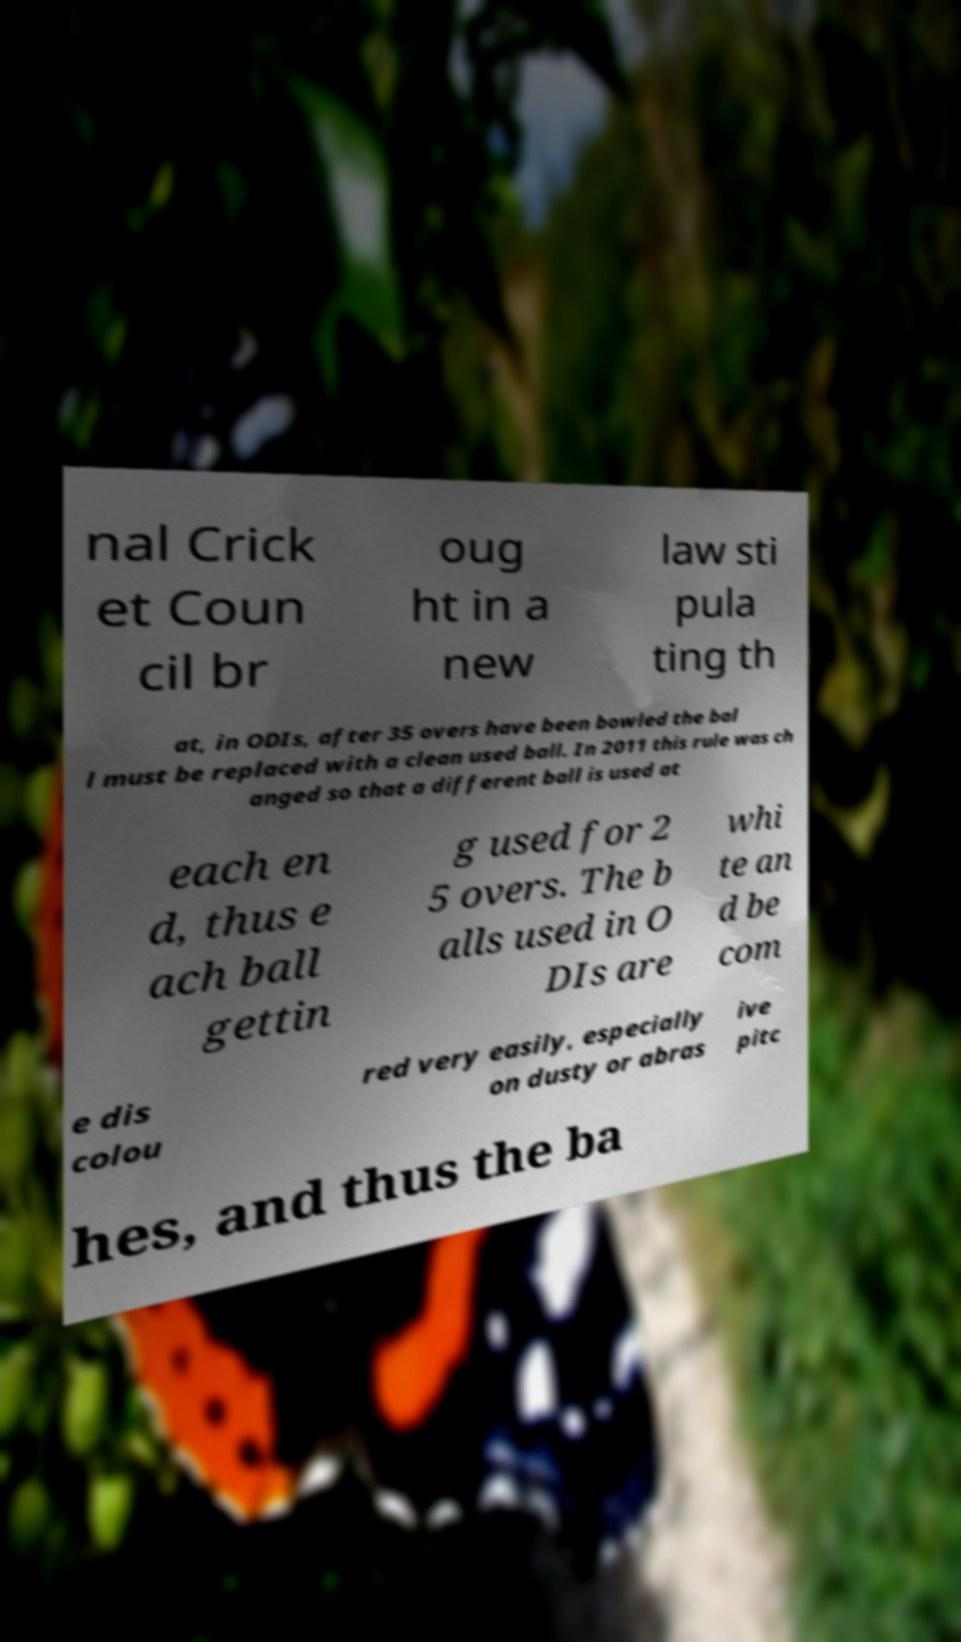What messages or text are displayed in this image? I need them in a readable, typed format. nal Crick et Coun cil br oug ht in a new law sti pula ting th at, in ODIs, after 35 overs have been bowled the bal l must be replaced with a clean used ball. In 2011 this rule was ch anged so that a different ball is used at each en d, thus e ach ball gettin g used for 2 5 overs. The b alls used in O DIs are whi te an d be com e dis colou red very easily, especially on dusty or abras ive pitc hes, and thus the ba 